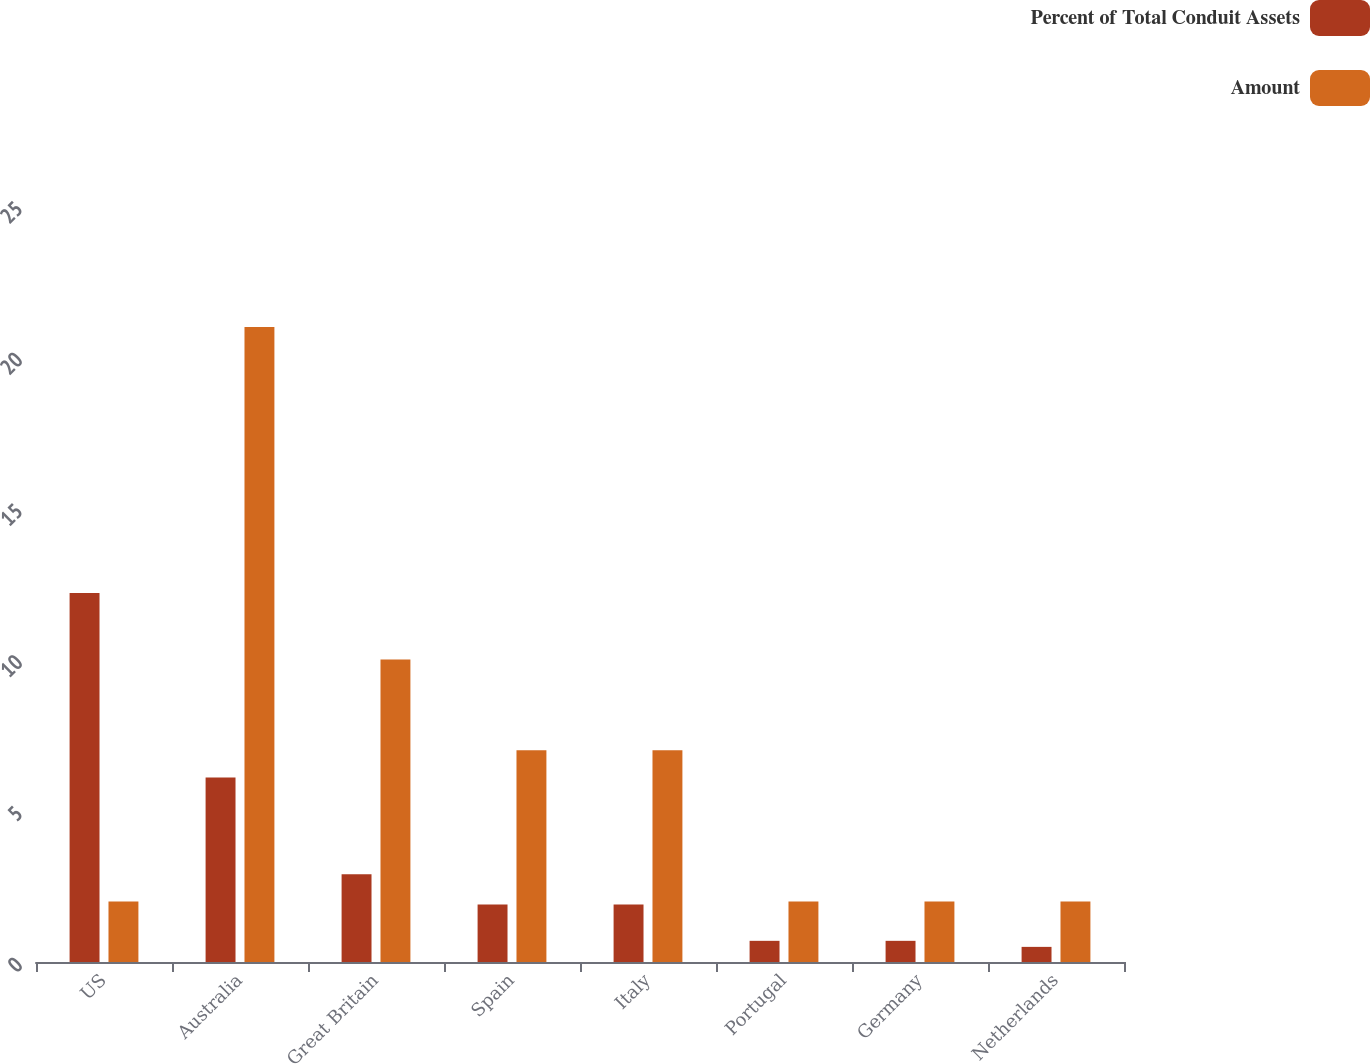Convert chart to OTSL. <chart><loc_0><loc_0><loc_500><loc_500><stacked_bar_chart><ecel><fcel>US<fcel>Australia<fcel>Great Britain<fcel>Spain<fcel>Italy<fcel>Portugal<fcel>Germany<fcel>Netherlands<nl><fcel>Percent of Total Conduit Assets<fcel>12.2<fcel>6.1<fcel>2.9<fcel>1.9<fcel>1.9<fcel>0.7<fcel>0.7<fcel>0.5<nl><fcel>Amount<fcel>2<fcel>21<fcel>10<fcel>7<fcel>7<fcel>2<fcel>2<fcel>2<nl></chart> 